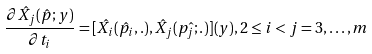<formula> <loc_0><loc_0><loc_500><loc_500>\frac { \partial \hat { X _ { j } } ( \hat { p } ; y ) } { \partial t _ { i } } = [ \hat { X _ { i } } ( \hat { p _ { i } } , . ) , \hat { X _ { j } } ( \hat { p _ { j } ; . } ) ] ( y ) , 2 \leq i < j = 3 , \dots , m</formula> 